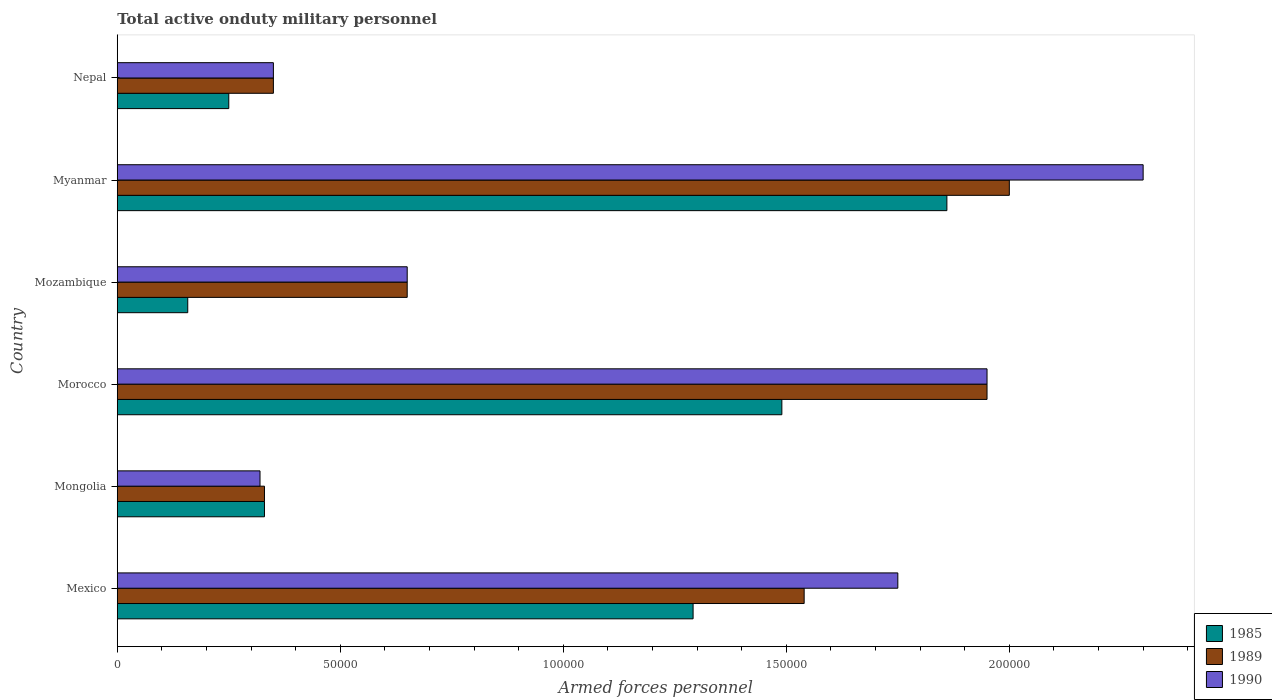How many groups of bars are there?
Offer a terse response. 6. Are the number of bars per tick equal to the number of legend labels?
Your answer should be compact. Yes. Are the number of bars on each tick of the Y-axis equal?
Offer a terse response. Yes. How many bars are there on the 5th tick from the top?
Your response must be concise. 3. What is the label of the 2nd group of bars from the top?
Your response must be concise. Myanmar. What is the number of armed forces personnel in 1989 in Mongolia?
Your response must be concise. 3.30e+04. Across all countries, what is the maximum number of armed forces personnel in 1985?
Ensure brevity in your answer.  1.86e+05. Across all countries, what is the minimum number of armed forces personnel in 1989?
Offer a very short reply. 3.30e+04. In which country was the number of armed forces personnel in 1985 maximum?
Offer a very short reply. Myanmar. In which country was the number of armed forces personnel in 1990 minimum?
Your answer should be very brief. Mongolia. What is the total number of armed forces personnel in 1985 in the graph?
Keep it short and to the point. 5.38e+05. What is the difference between the number of armed forces personnel in 1990 in Mexico and that in Myanmar?
Ensure brevity in your answer.  -5.50e+04. What is the difference between the number of armed forces personnel in 1985 in Myanmar and the number of armed forces personnel in 1990 in Mozambique?
Ensure brevity in your answer.  1.21e+05. What is the average number of armed forces personnel in 1990 per country?
Your answer should be compact. 1.22e+05. What is the ratio of the number of armed forces personnel in 1990 in Mongolia to that in Nepal?
Provide a short and direct response. 0.91. Is the difference between the number of armed forces personnel in 1990 in Mexico and Mongolia greater than the difference between the number of armed forces personnel in 1989 in Mexico and Mongolia?
Offer a terse response. Yes. What is the difference between the highest and the second highest number of armed forces personnel in 1989?
Offer a terse response. 5000. What is the difference between the highest and the lowest number of armed forces personnel in 1985?
Your response must be concise. 1.70e+05. In how many countries, is the number of armed forces personnel in 1990 greater than the average number of armed forces personnel in 1990 taken over all countries?
Keep it short and to the point. 3. Is the sum of the number of armed forces personnel in 1989 in Mongolia and Myanmar greater than the maximum number of armed forces personnel in 1985 across all countries?
Ensure brevity in your answer.  Yes. What does the 1st bar from the top in Morocco represents?
Your answer should be very brief. 1990. Is it the case that in every country, the sum of the number of armed forces personnel in 1989 and number of armed forces personnel in 1985 is greater than the number of armed forces personnel in 1990?
Provide a short and direct response. Yes. How many countries are there in the graph?
Your answer should be very brief. 6. What is the difference between two consecutive major ticks on the X-axis?
Ensure brevity in your answer.  5.00e+04. Are the values on the major ticks of X-axis written in scientific E-notation?
Your answer should be compact. No. Where does the legend appear in the graph?
Provide a succinct answer. Bottom right. How many legend labels are there?
Your answer should be very brief. 3. What is the title of the graph?
Keep it short and to the point. Total active onduty military personnel. Does "1980" appear as one of the legend labels in the graph?
Your response must be concise. No. What is the label or title of the X-axis?
Make the answer very short. Armed forces personnel. What is the Armed forces personnel of 1985 in Mexico?
Provide a short and direct response. 1.29e+05. What is the Armed forces personnel in 1989 in Mexico?
Your response must be concise. 1.54e+05. What is the Armed forces personnel in 1990 in Mexico?
Give a very brief answer. 1.75e+05. What is the Armed forces personnel in 1985 in Mongolia?
Ensure brevity in your answer.  3.30e+04. What is the Armed forces personnel of 1989 in Mongolia?
Give a very brief answer. 3.30e+04. What is the Armed forces personnel of 1990 in Mongolia?
Your answer should be very brief. 3.20e+04. What is the Armed forces personnel of 1985 in Morocco?
Offer a terse response. 1.49e+05. What is the Armed forces personnel in 1989 in Morocco?
Make the answer very short. 1.95e+05. What is the Armed forces personnel in 1990 in Morocco?
Your answer should be very brief. 1.95e+05. What is the Armed forces personnel of 1985 in Mozambique?
Make the answer very short. 1.58e+04. What is the Armed forces personnel in 1989 in Mozambique?
Your answer should be very brief. 6.50e+04. What is the Armed forces personnel in 1990 in Mozambique?
Your answer should be very brief. 6.50e+04. What is the Armed forces personnel in 1985 in Myanmar?
Your response must be concise. 1.86e+05. What is the Armed forces personnel of 1989 in Myanmar?
Offer a terse response. 2.00e+05. What is the Armed forces personnel of 1985 in Nepal?
Offer a terse response. 2.50e+04. What is the Armed forces personnel of 1989 in Nepal?
Your answer should be compact. 3.50e+04. What is the Armed forces personnel in 1990 in Nepal?
Make the answer very short. 3.50e+04. Across all countries, what is the maximum Armed forces personnel in 1985?
Provide a short and direct response. 1.86e+05. Across all countries, what is the maximum Armed forces personnel of 1989?
Provide a short and direct response. 2.00e+05. Across all countries, what is the maximum Armed forces personnel of 1990?
Your response must be concise. 2.30e+05. Across all countries, what is the minimum Armed forces personnel in 1985?
Offer a terse response. 1.58e+04. Across all countries, what is the minimum Armed forces personnel in 1989?
Ensure brevity in your answer.  3.30e+04. Across all countries, what is the minimum Armed forces personnel of 1990?
Your answer should be very brief. 3.20e+04. What is the total Armed forces personnel of 1985 in the graph?
Give a very brief answer. 5.38e+05. What is the total Armed forces personnel in 1989 in the graph?
Offer a terse response. 6.82e+05. What is the total Armed forces personnel in 1990 in the graph?
Offer a terse response. 7.32e+05. What is the difference between the Armed forces personnel of 1985 in Mexico and that in Mongolia?
Your answer should be compact. 9.61e+04. What is the difference between the Armed forces personnel in 1989 in Mexico and that in Mongolia?
Provide a short and direct response. 1.21e+05. What is the difference between the Armed forces personnel in 1990 in Mexico and that in Mongolia?
Offer a terse response. 1.43e+05. What is the difference between the Armed forces personnel in 1985 in Mexico and that in Morocco?
Keep it short and to the point. -1.99e+04. What is the difference between the Armed forces personnel in 1989 in Mexico and that in Morocco?
Offer a terse response. -4.10e+04. What is the difference between the Armed forces personnel of 1985 in Mexico and that in Mozambique?
Provide a succinct answer. 1.13e+05. What is the difference between the Armed forces personnel of 1989 in Mexico and that in Mozambique?
Give a very brief answer. 8.90e+04. What is the difference between the Armed forces personnel in 1990 in Mexico and that in Mozambique?
Provide a short and direct response. 1.10e+05. What is the difference between the Armed forces personnel in 1985 in Mexico and that in Myanmar?
Provide a short and direct response. -5.69e+04. What is the difference between the Armed forces personnel of 1989 in Mexico and that in Myanmar?
Make the answer very short. -4.60e+04. What is the difference between the Armed forces personnel in 1990 in Mexico and that in Myanmar?
Make the answer very short. -5.50e+04. What is the difference between the Armed forces personnel of 1985 in Mexico and that in Nepal?
Provide a short and direct response. 1.04e+05. What is the difference between the Armed forces personnel in 1989 in Mexico and that in Nepal?
Offer a terse response. 1.19e+05. What is the difference between the Armed forces personnel in 1990 in Mexico and that in Nepal?
Provide a short and direct response. 1.40e+05. What is the difference between the Armed forces personnel of 1985 in Mongolia and that in Morocco?
Your response must be concise. -1.16e+05. What is the difference between the Armed forces personnel of 1989 in Mongolia and that in Morocco?
Offer a very short reply. -1.62e+05. What is the difference between the Armed forces personnel in 1990 in Mongolia and that in Morocco?
Make the answer very short. -1.63e+05. What is the difference between the Armed forces personnel of 1985 in Mongolia and that in Mozambique?
Offer a very short reply. 1.72e+04. What is the difference between the Armed forces personnel of 1989 in Mongolia and that in Mozambique?
Keep it short and to the point. -3.20e+04. What is the difference between the Armed forces personnel in 1990 in Mongolia and that in Mozambique?
Provide a succinct answer. -3.30e+04. What is the difference between the Armed forces personnel of 1985 in Mongolia and that in Myanmar?
Your answer should be compact. -1.53e+05. What is the difference between the Armed forces personnel of 1989 in Mongolia and that in Myanmar?
Offer a very short reply. -1.67e+05. What is the difference between the Armed forces personnel in 1990 in Mongolia and that in Myanmar?
Your answer should be compact. -1.98e+05. What is the difference between the Armed forces personnel in 1985 in Mongolia and that in Nepal?
Make the answer very short. 8000. What is the difference between the Armed forces personnel of 1989 in Mongolia and that in Nepal?
Your answer should be very brief. -2000. What is the difference between the Armed forces personnel of 1990 in Mongolia and that in Nepal?
Your answer should be very brief. -3000. What is the difference between the Armed forces personnel in 1985 in Morocco and that in Mozambique?
Offer a very short reply. 1.33e+05. What is the difference between the Armed forces personnel of 1989 in Morocco and that in Mozambique?
Keep it short and to the point. 1.30e+05. What is the difference between the Armed forces personnel of 1990 in Morocco and that in Mozambique?
Your answer should be compact. 1.30e+05. What is the difference between the Armed forces personnel of 1985 in Morocco and that in Myanmar?
Your answer should be compact. -3.70e+04. What is the difference between the Armed forces personnel of 1989 in Morocco and that in Myanmar?
Your answer should be very brief. -5000. What is the difference between the Armed forces personnel of 1990 in Morocco and that in Myanmar?
Offer a very short reply. -3.50e+04. What is the difference between the Armed forces personnel in 1985 in Morocco and that in Nepal?
Your answer should be very brief. 1.24e+05. What is the difference between the Armed forces personnel of 1989 in Morocco and that in Nepal?
Provide a short and direct response. 1.60e+05. What is the difference between the Armed forces personnel in 1985 in Mozambique and that in Myanmar?
Give a very brief answer. -1.70e+05. What is the difference between the Armed forces personnel of 1989 in Mozambique and that in Myanmar?
Make the answer very short. -1.35e+05. What is the difference between the Armed forces personnel of 1990 in Mozambique and that in Myanmar?
Your response must be concise. -1.65e+05. What is the difference between the Armed forces personnel in 1985 in Mozambique and that in Nepal?
Provide a succinct answer. -9200. What is the difference between the Armed forces personnel of 1985 in Myanmar and that in Nepal?
Offer a very short reply. 1.61e+05. What is the difference between the Armed forces personnel in 1989 in Myanmar and that in Nepal?
Keep it short and to the point. 1.65e+05. What is the difference between the Armed forces personnel in 1990 in Myanmar and that in Nepal?
Keep it short and to the point. 1.95e+05. What is the difference between the Armed forces personnel of 1985 in Mexico and the Armed forces personnel of 1989 in Mongolia?
Give a very brief answer. 9.61e+04. What is the difference between the Armed forces personnel of 1985 in Mexico and the Armed forces personnel of 1990 in Mongolia?
Give a very brief answer. 9.71e+04. What is the difference between the Armed forces personnel of 1989 in Mexico and the Armed forces personnel of 1990 in Mongolia?
Ensure brevity in your answer.  1.22e+05. What is the difference between the Armed forces personnel of 1985 in Mexico and the Armed forces personnel of 1989 in Morocco?
Offer a terse response. -6.59e+04. What is the difference between the Armed forces personnel in 1985 in Mexico and the Armed forces personnel in 1990 in Morocco?
Ensure brevity in your answer.  -6.59e+04. What is the difference between the Armed forces personnel of 1989 in Mexico and the Armed forces personnel of 1990 in Morocco?
Your response must be concise. -4.10e+04. What is the difference between the Armed forces personnel in 1985 in Mexico and the Armed forces personnel in 1989 in Mozambique?
Ensure brevity in your answer.  6.41e+04. What is the difference between the Armed forces personnel of 1985 in Mexico and the Armed forces personnel of 1990 in Mozambique?
Your response must be concise. 6.41e+04. What is the difference between the Armed forces personnel of 1989 in Mexico and the Armed forces personnel of 1990 in Mozambique?
Keep it short and to the point. 8.90e+04. What is the difference between the Armed forces personnel of 1985 in Mexico and the Armed forces personnel of 1989 in Myanmar?
Your answer should be very brief. -7.09e+04. What is the difference between the Armed forces personnel in 1985 in Mexico and the Armed forces personnel in 1990 in Myanmar?
Offer a very short reply. -1.01e+05. What is the difference between the Armed forces personnel in 1989 in Mexico and the Armed forces personnel in 1990 in Myanmar?
Your response must be concise. -7.60e+04. What is the difference between the Armed forces personnel of 1985 in Mexico and the Armed forces personnel of 1989 in Nepal?
Give a very brief answer. 9.41e+04. What is the difference between the Armed forces personnel in 1985 in Mexico and the Armed forces personnel in 1990 in Nepal?
Give a very brief answer. 9.41e+04. What is the difference between the Armed forces personnel in 1989 in Mexico and the Armed forces personnel in 1990 in Nepal?
Ensure brevity in your answer.  1.19e+05. What is the difference between the Armed forces personnel of 1985 in Mongolia and the Armed forces personnel of 1989 in Morocco?
Ensure brevity in your answer.  -1.62e+05. What is the difference between the Armed forces personnel of 1985 in Mongolia and the Armed forces personnel of 1990 in Morocco?
Provide a short and direct response. -1.62e+05. What is the difference between the Armed forces personnel of 1989 in Mongolia and the Armed forces personnel of 1990 in Morocco?
Your answer should be compact. -1.62e+05. What is the difference between the Armed forces personnel of 1985 in Mongolia and the Armed forces personnel of 1989 in Mozambique?
Provide a short and direct response. -3.20e+04. What is the difference between the Armed forces personnel in 1985 in Mongolia and the Armed forces personnel in 1990 in Mozambique?
Your answer should be very brief. -3.20e+04. What is the difference between the Armed forces personnel in 1989 in Mongolia and the Armed forces personnel in 1990 in Mozambique?
Give a very brief answer. -3.20e+04. What is the difference between the Armed forces personnel of 1985 in Mongolia and the Armed forces personnel of 1989 in Myanmar?
Offer a very short reply. -1.67e+05. What is the difference between the Armed forces personnel of 1985 in Mongolia and the Armed forces personnel of 1990 in Myanmar?
Provide a short and direct response. -1.97e+05. What is the difference between the Armed forces personnel of 1989 in Mongolia and the Armed forces personnel of 1990 in Myanmar?
Offer a very short reply. -1.97e+05. What is the difference between the Armed forces personnel in 1985 in Mongolia and the Armed forces personnel in 1989 in Nepal?
Offer a terse response. -2000. What is the difference between the Armed forces personnel in 1985 in Mongolia and the Armed forces personnel in 1990 in Nepal?
Provide a short and direct response. -2000. What is the difference between the Armed forces personnel of 1989 in Mongolia and the Armed forces personnel of 1990 in Nepal?
Keep it short and to the point. -2000. What is the difference between the Armed forces personnel of 1985 in Morocco and the Armed forces personnel of 1989 in Mozambique?
Offer a very short reply. 8.40e+04. What is the difference between the Armed forces personnel of 1985 in Morocco and the Armed forces personnel of 1990 in Mozambique?
Ensure brevity in your answer.  8.40e+04. What is the difference between the Armed forces personnel in 1985 in Morocco and the Armed forces personnel in 1989 in Myanmar?
Your response must be concise. -5.10e+04. What is the difference between the Armed forces personnel in 1985 in Morocco and the Armed forces personnel in 1990 in Myanmar?
Give a very brief answer. -8.10e+04. What is the difference between the Armed forces personnel of 1989 in Morocco and the Armed forces personnel of 1990 in Myanmar?
Offer a terse response. -3.50e+04. What is the difference between the Armed forces personnel of 1985 in Morocco and the Armed forces personnel of 1989 in Nepal?
Give a very brief answer. 1.14e+05. What is the difference between the Armed forces personnel of 1985 in Morocco and the Armed forces personnel of 1990 in Nepal?
Make the answer very short. 1.14e+05. What is the difference between the Armed forces personnel of 1989 in Morocco and the Armed forces personnel of 1990 in Nepal?
Keep it short and to the point. 1.60e+05. What is the difference between the Armed forces personnel in 1985 in Mozambique and the Armed forces personnel in 1989 in Myanmar?
Ensure brevity in your answer.  -1.84e+05. What is the difference between the Armed forces personnel in 1985 in Mozambique and the Armed forces personnel in 1990 in Myanmar?
Provide a short and direct response. -2.14e+05. What is the difference between the Armed forces personnel in 1989 in Mozambique and the Armed forces personnel in 1990 in Myanmar?
Offer a terse response. -1.65e+05. What is the difference between the Armed forces personnel of 1985 in Mozambique and the Armed forces personnel of 1989 in Nepal?
Offer a very short reply. -1.92e+04. What is the difference between the Armed forces personnel of 1985 in Mozambique and the Armed forces personnel of 1990 in Nepal?
Your response must be concise. -1.92e+04. What is the difference between the Armed forces personnel in 1985 in Myanmar and the Armed forces personnel in 1989 in Nepal?
Your answer should be very brief. 1.51e+05. What is the difference between the Armed forces personnel in 1985 in Myanmar and the Armed forces personnel in 1990 in Nepal?
Provide a succinct answer. 1.51e+05. What is the difference between the Armed forces personnel of 1989 in Myanmar and the Armed forces personnel of 1990 in Nepal?
Give a very brief answer. 1.65e+05. What is the average Armed forces personnel in 1985 per country?
Ensure brevity in your answer.  8.96e+04. What is the average Armed forces personnel of 1989 per country?
Give a very brief answer. 1.14e+05. What is the average Armed forces personnel in 1990 per country?
Make the answer very short. 1.22e+05. What is the difference between the Armed forces personnel in 1985 and Armed forces personnel in 1989 in Mexico?
Offer a very short reply. -2.49e+04. What is the difference between the Armed forces personnel of 1985 and Armed forces personnel of 1990 in Mexico?
Provide a short and direct response. -4.59e+04. What is the difference between the Armed forces personnel in 1989 and Armed forces personnel in 1990 in Mexico?
Provide a succinct answer. -2.10e+04. What is the difference between the Armed forces personnel of 1985 and Armed forces personnel of 1989 in Mongolia?
Keep it short and to the point. 0. What is the difference between the Armed forces personnel in 1985 and Armed forces personnel in 1989 in Morocco?
Offer a very short reply. -4.60e+04. What is the difference between the Armed forces personnel in 1985 and Armed forces personnel in 1990 in Morocco?
Keep it short and to the point. -4.60e+04. What is the difference between the Armed forces personnel in 1985 and Armed forces personnel in 1989 in Mozambique?
Ensure brevity in your answer.  -4.92e+04. What is the difference between the Armed forces personnel in 1985 and Armed forces personnel in 1990 in Mozambique?
Provide a succinct answer. -4.92e+04. What is the difference between the Armed forces personnel of 1989 and Armed forces personnel of 1990 in Mozambique?
Your answer should be very brief. 0. What is the difference between the Armed forces personnel of 1985 and Armed forces personnel of 1989 in Myanmar?
Your answer should be compact. -1.40e+04. What is the difference between the Armed forces personnel in 1985 and Armed forces personnel in 1990 in Myanmar?
Keep it short and to the point. -4.40e+04. What is the difference between the Armed forces personnel of 1989 and Armed forces personnel of 1990 in Myanmar?
Offer a terse response. -3.00e+04. What is the difference between the Armed forces personnel of 1985 and Armed forces personnel of 1989 in Nepal?
Offer a very short reply. -10000. What is the difference between the Armed forces personnel of 1985 and Armed forces personnel of 1990 in Nepal?
Give a very brief answer. -10000. What is the difference between the Armed forces personnel of 1989 and Armed forces personnel of 1990 in Nepal?
Offer a terse response. 0. What is the ratio of the Armed forces personnel in 1985 in Mexico to that in Mongolia?
Give a very brief answer. 3.91. What is the ratio of the Armed forces personnel in 1989 in Mexico to that in Mongolia?
Offer a terse response. 4.67. What is the ratio of the Armed forces personnel in 1990 in Mexico to that in Mongolia?
Your answer should be compact. 5.47. What is the ratio of the Armed forces personnel of 1985 in Mexico to that in Morocco?
Your response must be concise. 0.87. What is the ratio of the Armed forces personnel of 1989 in Mexico to that in Morocco?
Keep it short and to the point. 0.79. What is the ratio of the Armed forces personnel of 1990 in Mexico to that in Morocco?
Your answer should be very brief. 0.9. What is the ratio of the Armed forces personnel of 1985 in Mexico to that in Mozambique?
Your answer should be very brief. 8.17. What is the ratio of the Armed forces personnel of 1989 in Mexico to that in Mozambique?
Your response must be concise. 2.37. What is the ratio of the Armed forces personnel of 1990 in Mexico to that in Mozambique?
Ensure brevity in your answer.  2.69. What is the ratio of the Armed forces personnel of 1985 in Mexico to that in Myanmar?
Provide a succinct answer. 0.69. What is the ratio of the Armed forces personnel in 1989 in Mexico to that in Myanmar?
Provide a succinct answer. 0.77. What is the ratio of the Armed forces personnel of 1990 in Mexico to that in Myanmar?
Your answer should be compact. 0.76. What is the ratio of the Armed forces personnel in 1985 in Mexico to that in Nepal?
Offer a very short reply. 5.16. What is the ratio of the Armed forces personnel in 1989 in Mexico to that in Nepal?
Your answer should be compact. 4.4. What is the ratio of the Armed forces personnel of 1990 in Mexico to that in Nepal?
Provide a short and direct response. 5. What is the ratio of the Armed forces personnel in 1985 in Mongolia to that in Morocco?
Keep it short and to the point. 0.22. What is the ratio of the Armed forces personnel in 1989 in Mongolia to that in Morocco?
Offer a very short reply. 0.17. What is the ratio of the Armed forces personnel in 1990 in Mongolia to that in Morocco?
Your response must be concise. 0.16. What is the ratio of the Armed forces personnel of 1985 in Mongolia to that in Mozambique?
Provide a succinct answer. 2.09. What is the ratio of the Armed forces personnel of 1989 in Mongolia to that in Mozambique?
Make the answer very short. 0.51. What is the ratio of the Armed forces personnel of 1990 in Mongolia to that in Mozambique?
Your answer should be compact. 0.49. What is the ratio of the Armed forces personnel of 1985 in Mongolia to that in Myanmar?
Provide a short and direct response. 0.18. What is the ratio of the Armed forces personnel of 1989 in Mongolia to that in Myanmar?
Provide a short and direct response. 0.17. What is the ratio of the Armed forces personnel of 1990 in Mongolia to that in Myanmar?
Offer a very short reply. 0.14. What is the ratio of the Armed forces personnel in 1985 in Mongolia to that in Nepal?
Ensure brevity in your answer.  1.32. What is the ratio of the Armed forces personnel in 1989 in Mongolia to that in Nepal?
Ensure brevity in your answer.  0.94. What is the ratio of the Armed forces personnel of 1990 in Mongolia to that in Nepal?
Your answer should be very brief. 0.91. What is the ratio of the Armed forces personnel in 1985 in Morocco to that in Mozambique?
Ensure brevity in your answer.  9.43. What is the ratio of the Armed forces personnel in 1989 in Morocco to that in Mozambique?
Provide a succinct answer. 3. What is the ratio of the Armed forces personnel of 1990 in Morocco to that in Mozambique?
Provide a succinct answer. 3. What is the ratio of the Armed forces personnel in 1985 in Morocco to that in Myanmar?
Your response must be concise. 0.8. What is the ratio of the Armed forces personnel of 1990 in Morocco to that in Myanmar?
Give a very brief answer. 0.85. What is the ratio of the Armed forces personnel of 1985 in Morocco to that in Nepal?
Keep it short and to the point. 5.96. What is the ratio of the Armed forces personnel of 1989 in Morocco to that in Nepal?
Offer a very short reply. 5.57. What is the ratio of the Armed forces personnel in 1990 in Morocco to that in Nepal?
Your answer should be compact. 5.57. What is the ratio of the Armed forces personnel in 1985 in Mozambique to that in Myanmar?
Offer a very short reply. 0.08. What is the ratio of the Armed forces personnel of 1989 in Mozambique to that in Myanmar?
Your answer should be very brief. 0.33. What is the ratio of the Armed forces personnel of 1990 in Mozambique to that in Myanmar?
Keep it short and to the point. 0.28. What is the ratio of the Armed forces personnel in 1985 in Mozambique to that in Nepal?
Offer a very short reply. 0.63. What is the ratio of the Armed forces personnel of 1989 in Mozambique to that in Nepal?
Your answer should be very brief. 1.86. What is the ratio of the Armed forces personnel of 1990 in Mozambique to that in Nepal?
Make the answer very short. 1.86. What is the ratio of the Armed forces personnel in 1985 in Myanmar to that in Nepal?
Keep it short and to the point. 7.44. What is the ratio of the Armed forces personnel of 1989 in Myanmar to that in Nepal?
Ensure brevity in your answer.  5.71. What is the ratio of the Armed forces personnel in 1990 in Myanmar to that in Nepal?
Give a very brief answer. 6.57. What is the difference between the highest and the second highest Armed forces personnel in 1985?
Your answer should be very brief. 3.70e+04. What is the difference between the highest and the second highest Armed forces personnel of 1990?
Keep it short and to the point. 3.50e+04. What is the difference between the highest and the lowest Armed forces personnel of 1985?
Your answer should be compact. 1.70e+05. What is the difference between the highest and the lowest Armed forces personnel in 1989?
Give a very brief answer. 1.67e+05. What is the difference between the highest and the lowest Armed forces personnel in 1990?
Provide a short and direct response. 1.98e+05. 